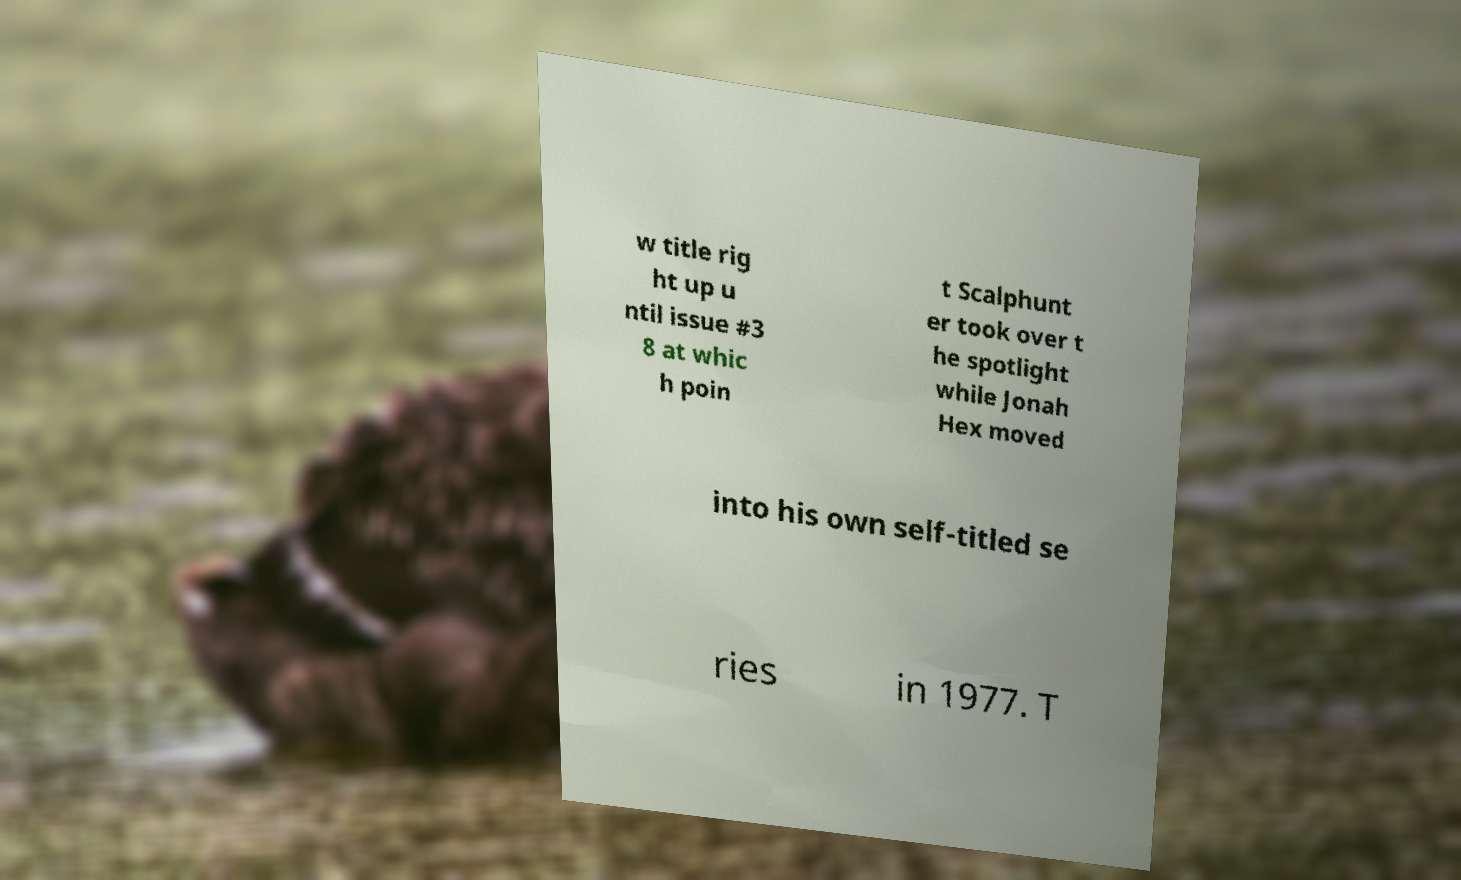What messages or text are displayed in this image? I need them in a readable, typed format. w title rig ht up u ntil issue #3 8 at whic h poin t Scalphunt er took over t he spotlight while Jonah Hex moved into his own self-titled se ries in 1977. T 